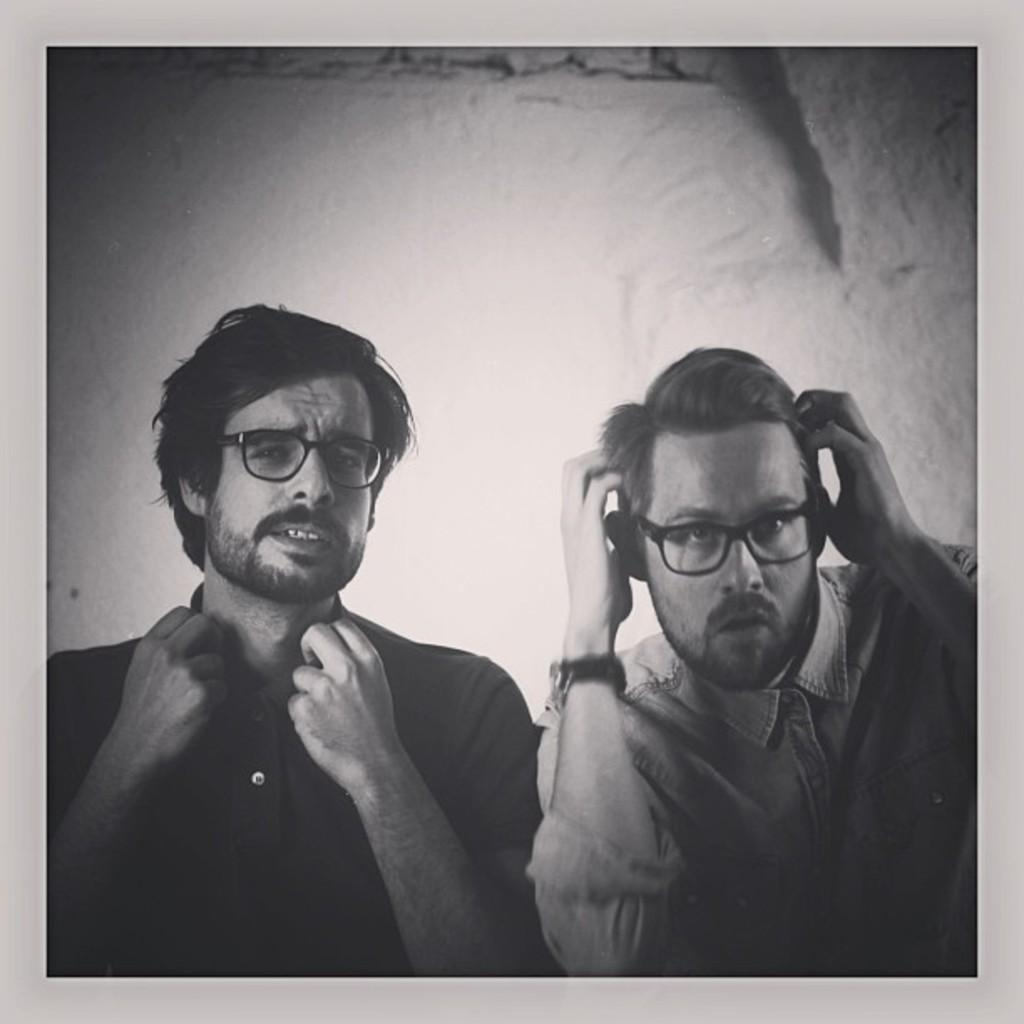What is the color scheme of the image? The image is black and white. How many people are in the image? There are two men standing in the image. What are the men wearing on their upper bodies? Both men are wearing shirts. What accessory do both men have in common? Both men are wearing spectacles. What action is one of the men performing? One of the men appears to be adjusting his hair. What type of background can be seen in the image? There is a wall visible in the image. What type of grain can be seen growing on the road in the image? There is no grain or road present in the image; it features two men standing in front of a wall. 